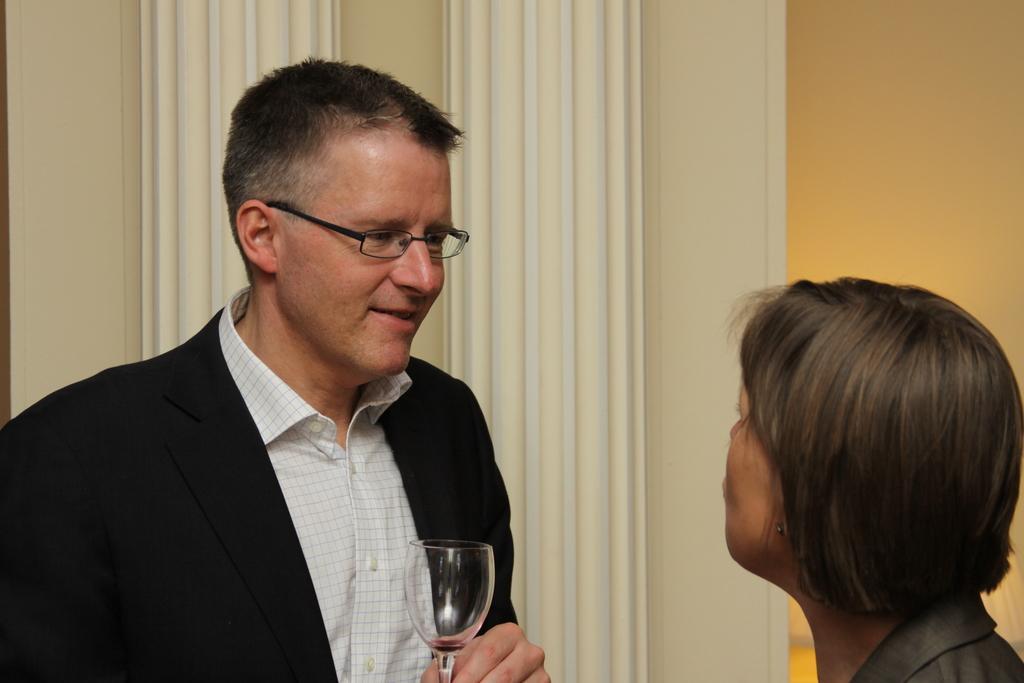In one or two sentences, can you explain what this image depicts? In the image we can see there are people who are standing and the man is holding wine glass in his hand. 